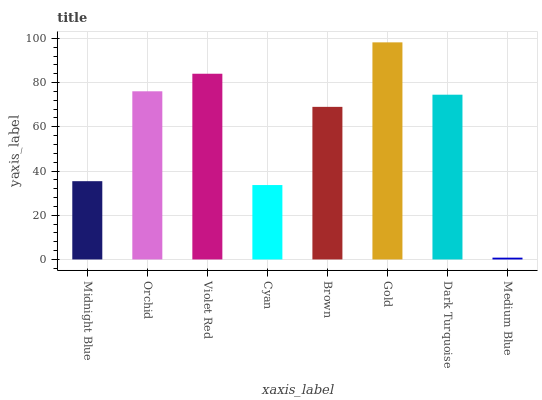Is Medium Blue the minimum?
Answer yes or no. Yes. Is Gold the maximum?
Answer yes or no. Yes. Is Orchid the minimum?
Answer yes or no. No. Is Orchid the maximum?
Answer yes or no. No. Is Orchid greater than Midnight Blue?
Answer yes or no. Yes. Is Midnight Blue less than Orchid?
Answer yes or no. Yes. Is Midnight Blue greater than Orchid?
Answer yes or no. No. Is Orchid less than Midnight Blue?
Answer yes or no. No. Is Dark Turquoise the high median?
Answer yes or no. Yes. Is Brown the low median?
Answer yes or no. Yes. Is Cyan the high median?
Answer yes or no. No. Is Dark Turquoise the low median?
Answer yes or no. No. 